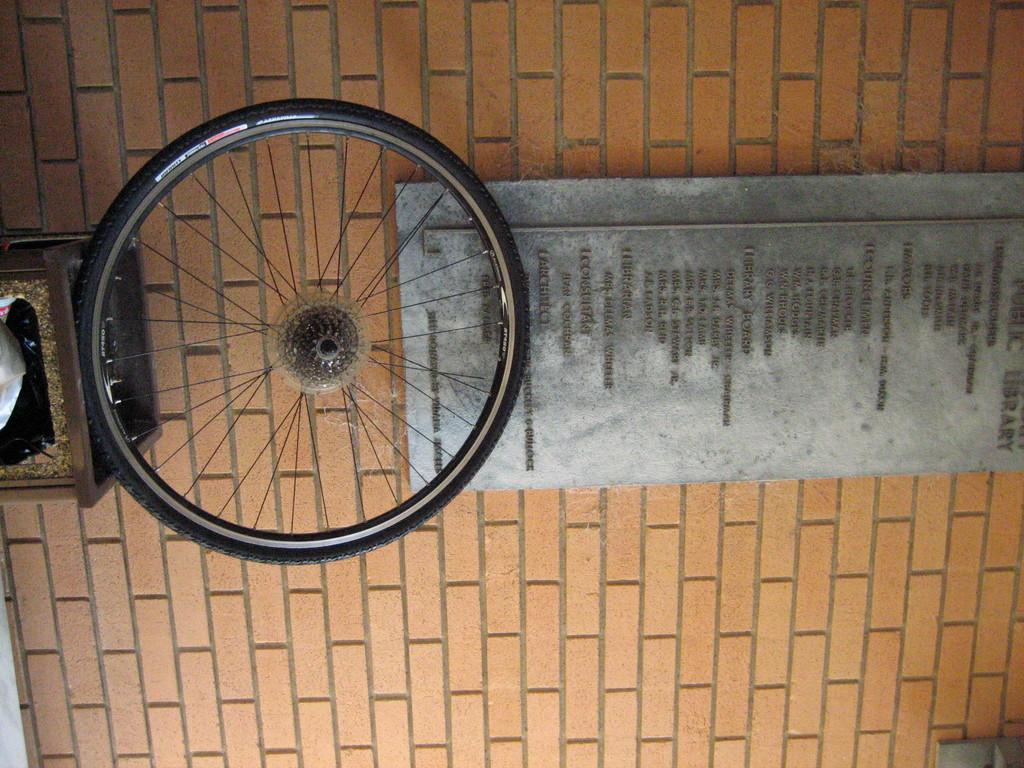What object in the image has a wheel? There is a wheel on a dustbin in the image. What can be seen on the wall in the image? There is a board on the wall in the image. What is written or displayed on the board? The board has text on it. What type of appliance is shown on the board in the image? There is no appliance shown on the board in the image; it only has text. What type of grain is visible in the image? There is no grain visible in the image. 